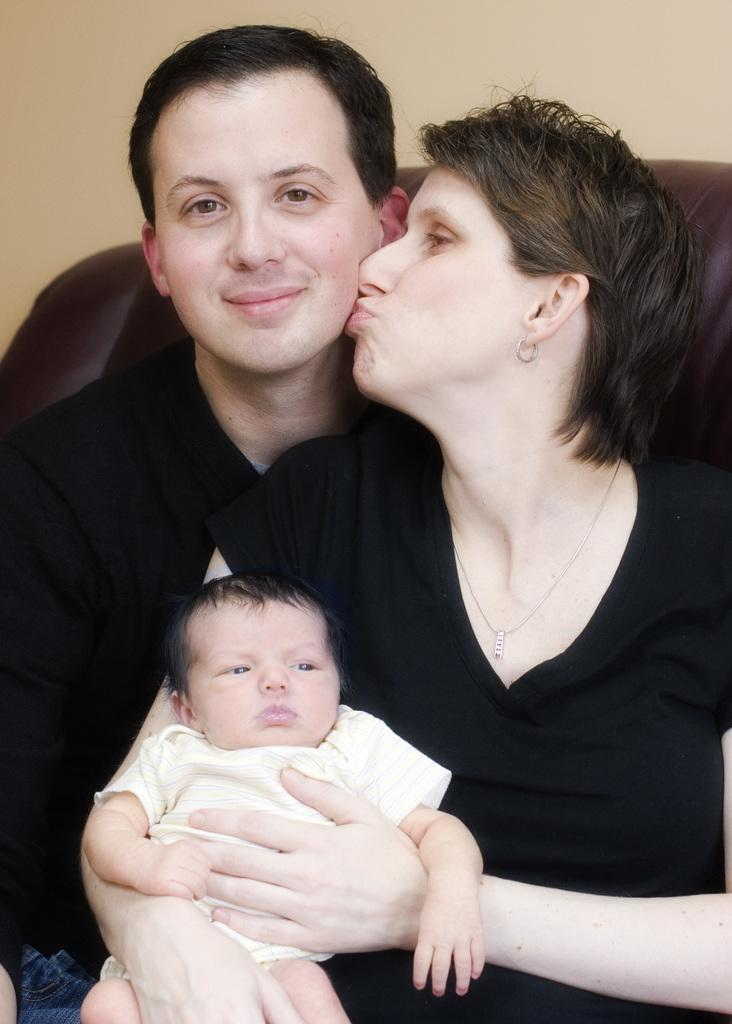How many people are present in the image? There are two people sitting in the image. What is one of the people doing with their hands? One of the people is holding a baby. What can be seen in the background of the image? There is a wall visible in the background of the image. What type of flight is the baby taking in the image? There is no flight present in the image; it features two people sitting and one of them holding a baby. What show is the baby watching in the image? There is no show present in the image; it features two people sitting and one of them holding a baby. 